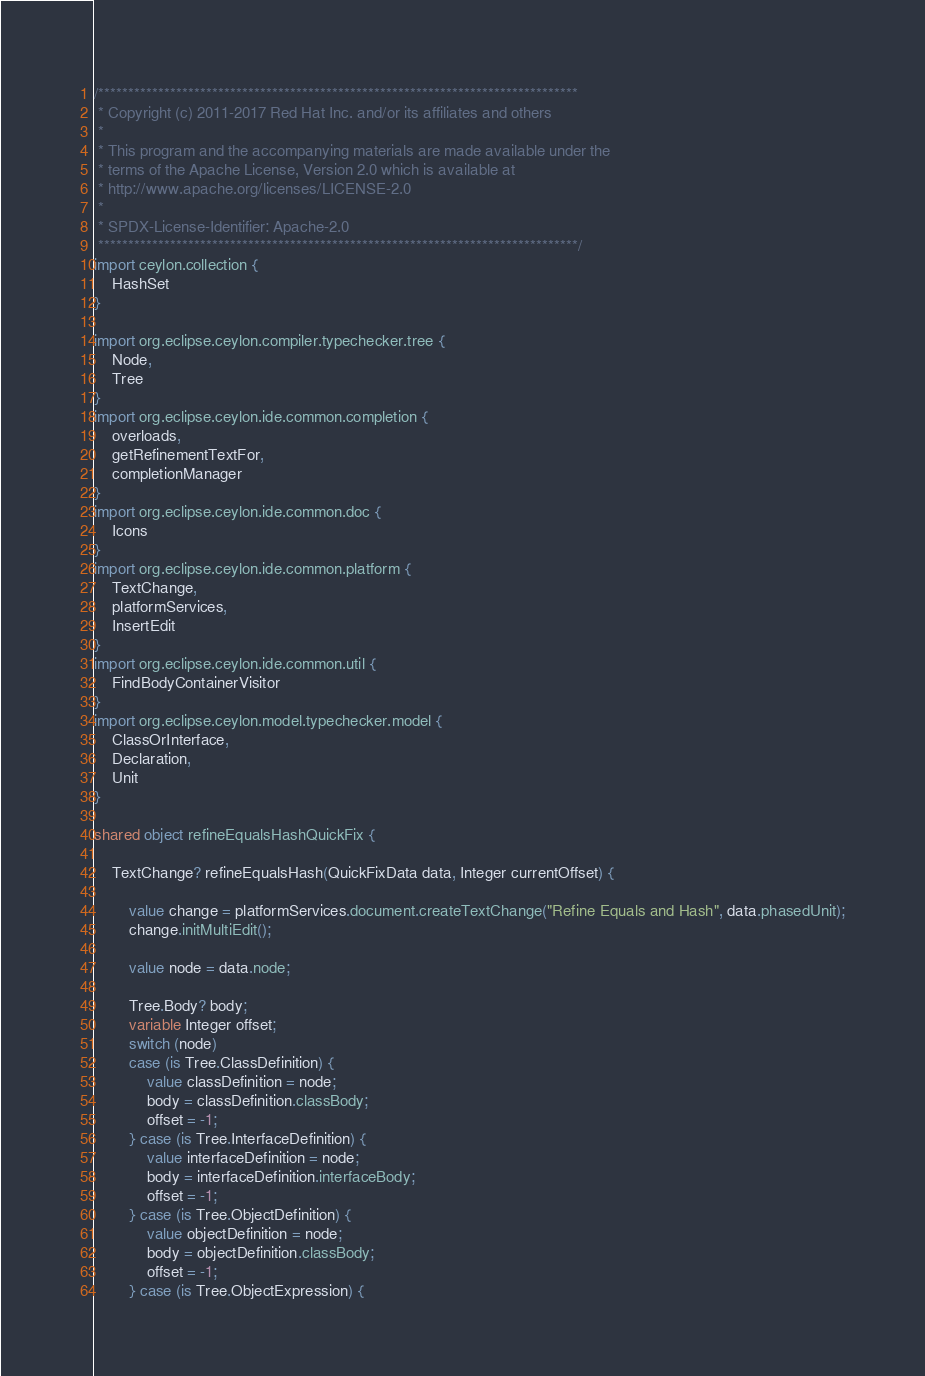Convert code to text. <code><loc_0><loc_0><loc_500><loc_500><_Ceylon_>/********************************************************************************
 * Copyright (c) 2011-2017 Red Hat Inc. and/or its affiliates and others
 *
 * This program and the accompanying materials are made available under the 
 * terms of the Apache License, Version 2.0 which is available at
 * http://www.apache.org/licenses/LICENSE-2.0
 *
 * SPDX-License-Identifier: Apache-2.0 
 ********************************************************************************/
import ceylon.collection {
    HashSet
}

import org.eclipse.ceylon.compiler.typechecker.tree {
    Node,
    Tree
}
import org.eclipse.ceylon.ide.common.completion {
    overloads,
    getRefinementTextFor,
    completionManager
}
import org.eclipse.ceylon.ide.common.doc {
    Icons
}
import org.eclipse.ceylon.ide.common.platform {
    TextChange,
    platformServices,
    InsertEdit
}
import org.eclipse.ceylon.ide.common.util {
    FindBodyContainerVisitor
}
import org.eclipse.ceylon.model.typechecker.model {
    ClassOrInterface,
    Declaration,
    Unit
}

shared object refineEqualsHashQuickFix {

    TextChange? refineEqualsHash(QuickFixData data, Integer currentOffset) {

        value change = platformServices.document.createTextChange("Refine Equals and Hash", data.phasedUnit);
        change.initMultiEdit();
        
        value node = data.node;
        
        Tree.Body? body;
        variable Integer offset;
        switch (node)
        case (is Tree.ClassDefinition) {
            value classDefinition = node;
            body = classDefinition.classBody;
            offset = -1;
        } case (is Tree.InterfaceDefinition) {
            value interfaceDefinition = node;
            body = interfaceDefinition.interfaceBody;
            offset = -1;
        } case (is Tree.ObjectDefinition) {
            value objectDefinition = node;
            body = objectDefinition.classBody;
            offset = -1;
        } case (is Tree.ObjectExpression) {</code> 